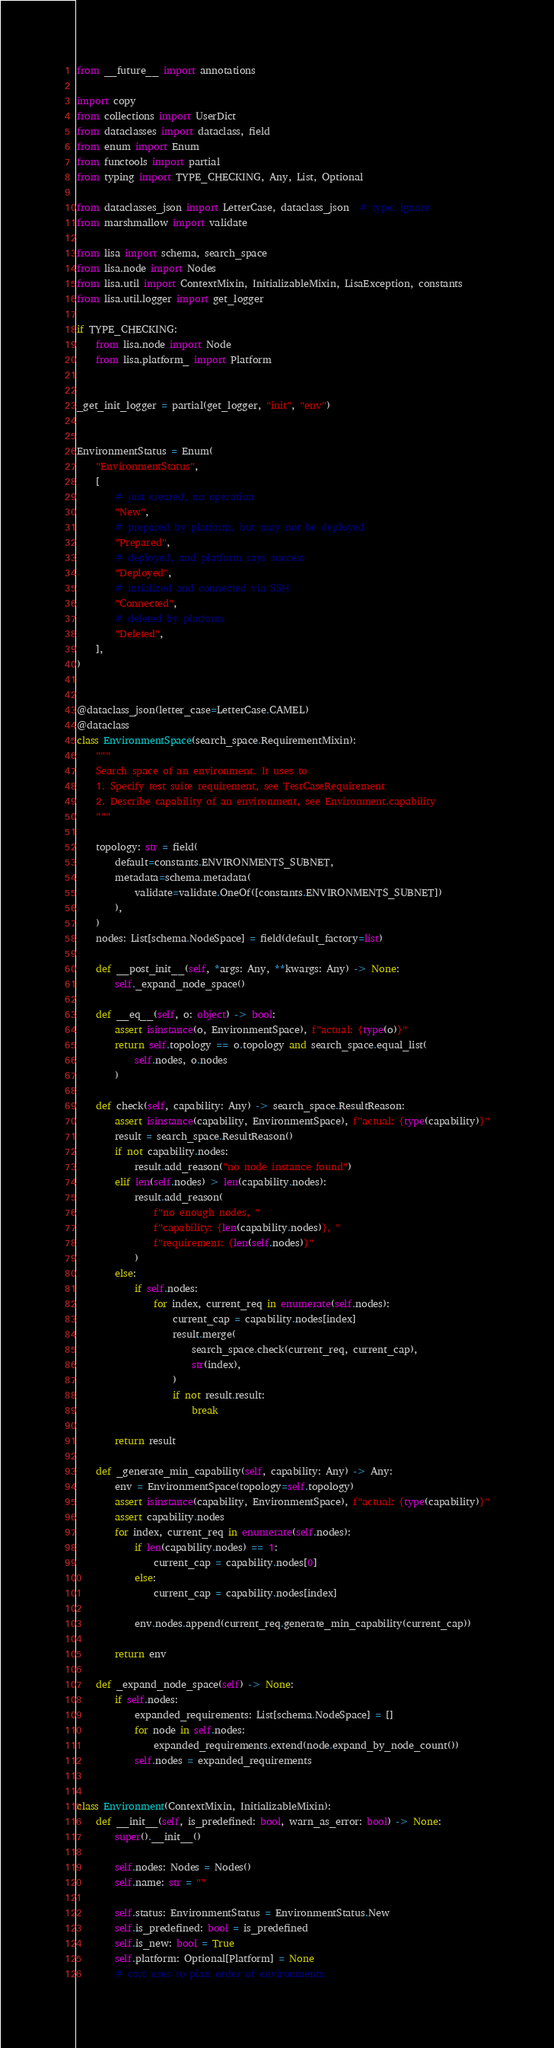Convert code to text. <code><loc_0><loc_0><loc_500><loc_500><_Python_>from __future__ import annotations

import copy
from collections import UserDict
from dataclasses import dataclass, field
from enum import Enum
from functools import partial
from typing import TYPE_CHECKING, Any, List, Optional

from dataclasses_json import LetterCase, dataclass_json  # type: ignore
from marshmallow import validate

from lisa import schema, search_space
from lisa.node import Nodes
from lisa.util import ContextMixin, InitializableMixin, LisaException, constants
from lisa.util.logger import get_logger

if TYPE_CHECKING:
    from lisa.node import Node
    from lisa.platform_ import Platform


_get_init_logger = partial(get_logger, "init", "env")


EnvironmentStatus = Enum(
    "EnvironmentStatus",
    [
        # just created, no operation
        "New",
        # prepared by platform, but may not be deployed
        "Prepared",
        # deployed, and platform says success
        "Deployed",
        # intialized and connected via SSH
        "Connected",
        # deleted by platform
        "Deleted",
    ],
)


@dataclass_json(letter_case=LetterCase.CAMEL)
@dataclass
class EnvironmentSpace(search_space.RequirementMixin):
    """
    Search space of an environment. It uses to
    1. Specify test suite requirement, see TestCaseRequirement
    2. Describe capability of an environment, see Environment.capability
    """

    topology: str = field(
        default=constants.ENVIRONMENTS_SUBNET,
        metadata=schema.metadata(
            validate=validate.OneOf([constants.ENVIRONMENTS_SUBNET])
        ),
    )
    nodes: List[schema.NodeSpace] = field(default_factory=list)

    def __post_init__(self, *args: Any, **kwargs: Any) -> None:
        self._expand_node_space()

    def __eq__(self, o: object) -> bool:
        assert isinstance(o, EnvironmentSpace), f"actual: {type(o)}"
        return self.topology == o.topology and search_space.equal_list(
            self.nodes, o.nodes
        )

    def check(self, capability: Any) -> search_space.ResultReason:
        assert isinstance(capability, EnvironmentSpace), f"actual: {type(capability)}"
        result = search_space.ResultReason()
        if not capability.nodes:
            result.add_reason("no node instance found")
        elif len(self.nodes) > len(capability.nodes):
            result.add_reason(
                f"no enough nodes, "
                f"capability: {len(capability.nodes)}, "
                f"requirement: {len(self.nodes)}"
            )
        else:
            if self.nodes:
                for index, current_req in enumerate(self.nodes):
                    current_cap = capability.nodes[index]
                    result.merge(
                        search_space.check(current_req, current_cap),
                        str(index),
                    )
                    if not result.result:
                        break

        return result

    def _generate_min_capability(self, capability: Any) -> Any:
        env = EnvironmentSpace(topology=self.topology)
        assert isinstance(capability, EnvironmentSpace), f"actual: {type(capability)}"
        assert capability.nodes
        for index, current_req in enumerate(self.nodes):
            if len(capability.nodes) == 1:
                current_cap = capability.nodes[0]
            else:
                current_cap = capability.nodes[index]

            env.nodes.append(current_req.generate_min_capability(current_cap))

        return env

    def _expand_node_space(self) -> None:
        if self.nodes:
            expanded_requirements: List[schema.NodeSpace] = []
            for node in self.nodes:
                expanded_requirements.extend(node.expand_by_node_count())
            self.nodes = expanded_requirements


class Environment(ContextMixin, InitializableMixin):
    def __init__(self, is_predefined: bool, warn_as_error: bool) -> None:
        super().__init__()

        self.nodes: Nodes = Nodes()
        self.name: str = ""

        self.status: EnvironmentStatus = EnvironmentStatus.New
        self.is_predefined: bool = is_predefined
        self.is_new: bool = True
        self.platform: Optional[Platform] = None
        # cost uses to plan order of environments.</code> 